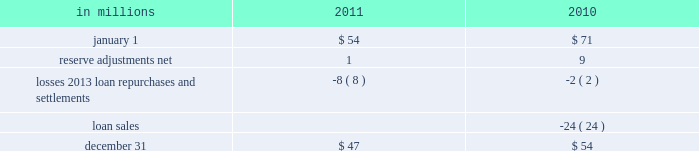Recourse and repurchase obligations as discussed in note 3 loans sale and servicing activities and variable interest entities , pnc has sold commercial mortgage and residential mortgage loans directly or indirectly in securitizations and whole-loan sale transactions with continuing involvement .
One form of continuing involvement includes certain recourse and loan repurchase obligations associated with the transferred assets in these transactions .
Commercial mortgage loan recourse obligations we originate , close and service certain multi-family commercial mortgage loans which are sold to fnma under fnma 2019s dus program .
We participated in a similar program with the fhlmc .
Under these programs , we generally assume up to a one-third pari passu risk of loss on unpaid principal balances through a loss share arrangement .
At december 31 , 2011 and december 31 , 2010 , the unpaid principal balance outstanding of loans sold as a participant in these programs was $ 13.0 billion and $ 13.2 billion , respectively .
The potential maximum exposure under the loss share arrangements was $ 4.0 billion at both december 31 , 2011 and december 31 , 2010 .
We maintain a reserve for estimated losses based upon our exposure .
The reserve for losses under these programs totaled $ 47 million and $ 54 million as of december 31 , 2011 and december 31 , 2010 , respectively , and is included in other liabilities on our consolidated balance sheet .
If payment is required under these programs , we would not have a contractual interest in the collateral underlying the mortgage loans on which losses occurred , although the value of the collateral is taken into account in determining our share of such losses .
Our exposure and activity associated with these recourse obligations are reported in the corporate & institutional banking segment .
Analysis of commercial mortgage recourse obligations .
Residential mortgage loan and home equity repurchase obligations while residential mortgage loans are sold on a non-recourse basis , we assume certain loan repurchase obligations associated with mortgage loans we have sold to investors .
These loan repurchase obligations primarily relate to situations where pnc is alleged to have breached certain origination covenants and representations and warranties made to purchasers of the loans in the respective purchase and sale agreements .
Residential mortgage loans covered by these loan repurchase obligations include first and second-lien mortgage loans we have sold through agency securitizations , non-agency securitizations , and whole-loan sale transactions .
As discussed in note 3 in this report , agency securitizations consist of mortgage loans sale transactions with fnma , fhlmc , and gnma , while non-agency securitizations and whole-loan sale transactions consist of mortgage loans sale transactions with private investors .
Our historical exposure and activity associated with agency securitization repurchase obligations has primarily been related to transactions with fnma and fhlmc , as indemnification and repurchase losses associated with fha and va-insured and uninsured loans pooled in gnma securitizations historically have been minimal .
Repurchase obligation activity associated with residential mortgages is reported in the residential mortgage banking segment .
Pnc 2019s repurchase obligations also include certain brokered home equity loans/lines that were sold to a limited number of private investors in the financial services industry by national city prior to our acquisition .
Pnc is no longer engaged in the brokered home equity lending business , and our exposure under these loan repurchase obligations is limited to repurchases of whole-loans sold in these transactions .
Repurchase activity associated with brokered home equity loans/lines is reported in the non-strategic assets portfolio segment .
Loan covenants and representations and warranties are established through loan sale agreements with various investors to provide assurance that pnc has sold loans to investors of sufficient investment quality .
Key aspects of such covenants and representations and warranties include the loan 2019s compliance with any applicable loan criteria established by the investor , including underwriting standards , delivery of all required loan documents to the investor or its designated party , sufficient collateral valuation , and the validity of the lien securing the loan .
As a result of alleged breaches of these contractual obligations , investors may request pnc to indemnify them against losses on certain loans or to repurchase loans .
These investor indemnification or repurchase claims are typically settled on an individual loan basis through make- whole payments or loan repurchases ; however , on occasion we may negotiate pooled settlements with investors .
Indemnifications for loss or loan repurchases typically occur when , after review of the claim , we agree insufficient evidence exists to dispute the investor 2019s claim that a breach of a loan covenant and representation and warranty has occurred , such breach has not been cured , and the effect of such breach is deemed to have had a material and adverse effect on the value of the transferred loan .
Depending on the sale agreement and upon proper notice from the investor , we typically respond to such indemnification and repurchase requests within 60 days , although final resolution of the claim may take a longer period of time .
With the exception of the sales the pnc financial services group , inc .
2013 form 10-k 199 .
During 2011 , what was the change in reserve for estimated losses included in other liabilities on our consolidated balance sheet? 
Computations: (54 - 47)
Answer: 7.0. 